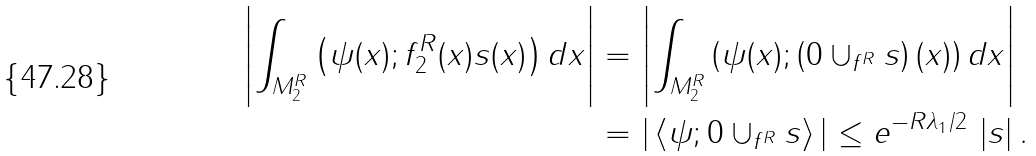<formula> <loc_0><loc_0><loc_500><loc_500>\left | \int _ { M _ { 2 } ^ { R } } \left ( \psi ( x ) ; f _ { 2 } ^ { R } ( x ) s ( x ) \right ) d x \right | & = \left | \int _ { M _ { 2 } ^ { R } } \left ( \psi ( x ) ; \left ( 0 \cup _ { f ^ { R } } s \right ) ( x ) \right ) d x \right | \\ & = | \left \langle \psi ; 0 \cup _ { f ^ { R } } s \right \rangle | \leq e ^ { - R \lambda _ { 1 } / 2 } \, \left | s \right | .</formula> 